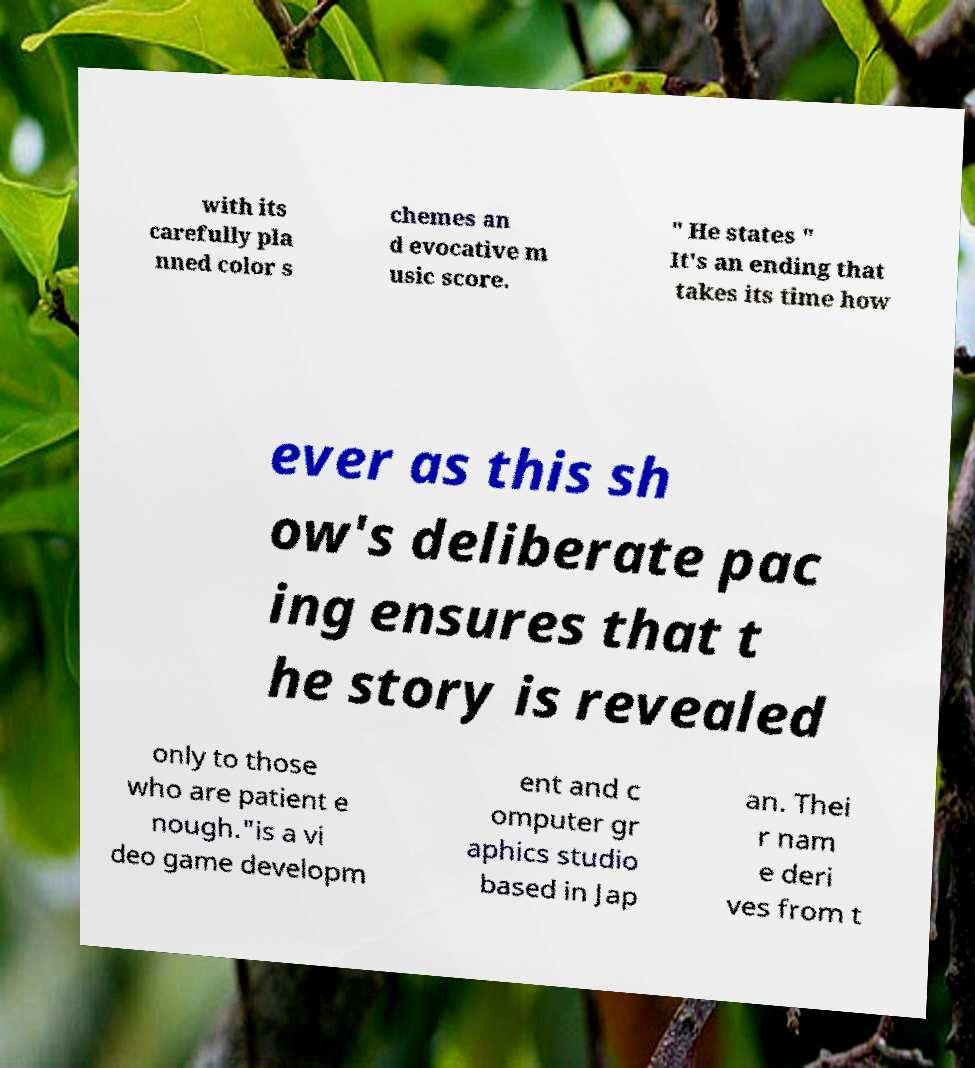Please identify and transcribe the text found in this image. with its carefully pla nned color s chemes an d evocative m usic score. " He states " It's an ending that takes its time how ever as this sh ow's deliberate pac ing ensures that t he story is revealed only to those who are patient e nough."is a vi deo game developm ent and c omputer gr aphics studio based in Jap an. Thei r nam e deri ves from t 